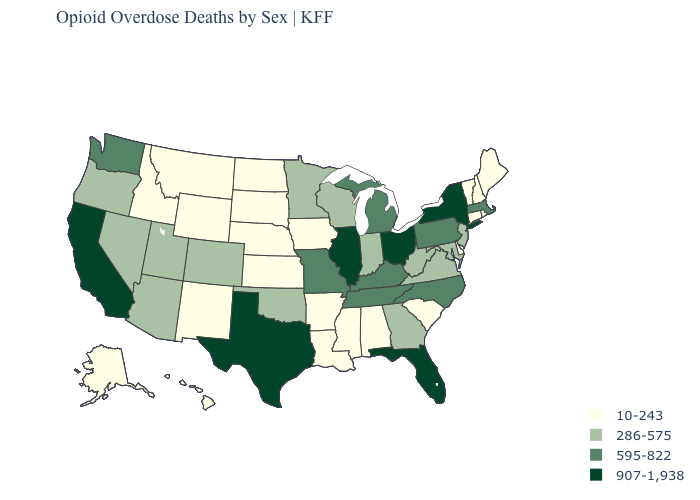Name the states that have a value in the range 595-822?
Concise answer only. Kentucky, Massachusetts, Michigan, Missouri, North Carolina, Pennsylvania, Tennessee, Washington. What is the value of South Carolina?
Give a very brief answer. 10-243. Name the states that have a value in the range 595-822?
Write a very short answer. Kentucky, Massachusetts, Michigan, Missouri, North Carolina, Pennsylvania, Tennessee, Washington. What is the value of California?
Concise answer only. 907-1,938. Which states have the lowest value in the USA?
Write a very short answer. Alabama, Alaska, Arkansas, Connecticut, Delaware, Hawaii, Idaho, Iowa, Kansas, Louisiana, Maine, Mississippi, Montana, Nebraska, New Hampshire, New Mexico, North Dakota, Rhode Island, South Carolina, South Dakota, Vermont, Wyoming. Name the states that have a value in the range 10-243?
Quick response, please. Alabama, Alaska, Arkansas, Connecticut, Delaware, Hawaii, Idaho, Iowa, Kansas, Louisiana, Maine, Mississippi, Montana, Nebraska, New Hampshire, New Mexico, North Dakota, Rhode Island, South Carolina, South Dakota, Vermont, Wyoming. Name the states that have a value in the range 907-1,938?
Quick response, please. California, Florida, Illinois, New York, Ohio, Texas. What is the value of Kentucky?
Give a very brief answer. 595-822. Which states have the highest value in the USA?
Answer briefly. California, Florida, Illinois, New York, Ohio, Texas. Among the states that border West Virginia , which have the highest value?
Answer briefly. Ohio. Name the states that have a value in the range 595-822?
Short answer required. Kentucky, Massachusetts, Michigan, Missouri, North Carolina, Pennsylvania, Tennessee, Washington. What is the value of Georgia?
Give a very brief answer. 286-575. What is the lowest value in states that border Kansas?
Keep it brief. 10-243. Is the legend a continuous bar?
Answer briefly. No. How many symbols are there in the legend?
Be succinct. 4. 